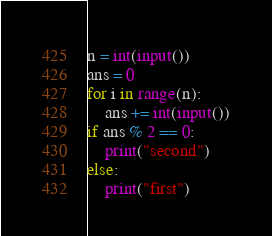Convert code to text. <code><loc_0><loc_0><loc_500><loc_500><_Python_>n = int(input())
ans = 0
for i in range(n):
    ans += int(input())
if ans % 2 == 0:
    print("second")
else:
    print("first")</code> 